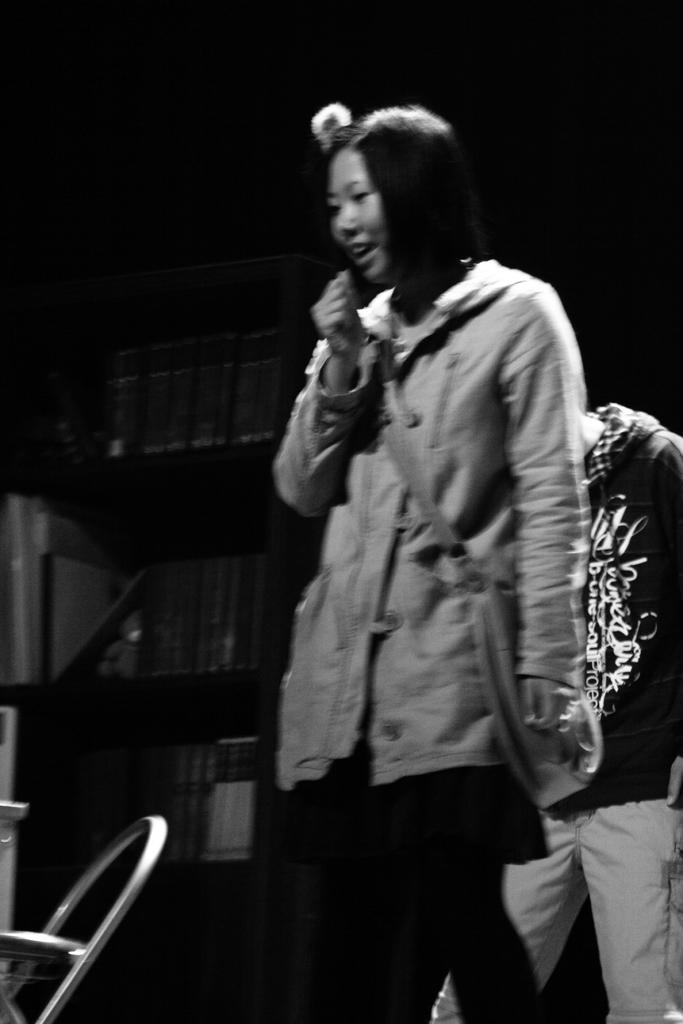Can you describe this image briefly? In this image I can see the black and white picture in which I can see two persons standing, a chair, few other objects and the dark background. 